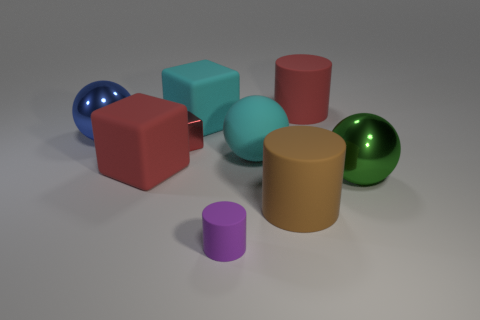Add 1 big brown rubber objects. How many objects exist? 10 Subtract all large blue balls. How many balls are left? 2 Subtract 1 cubes. How many cubes are left? 2 Add 6 yellow cylinders. How many yellow cylinders exist? 6 Subtract all cyan blocks. How many blocks are left? 2 Subtract 0 blue blocks. How many objects are left? 9 Subtract all cubes. How many objects are left? 6 Subtract all brown spheres. Subtract all cyan cylinders. How many spheres are left? 3 Subtract all cyan blocks. How many cyan cylinders are left? 0 Subtract all large brown rubber things. Subtract all purple rubber cylinders. How many objects are left? 7 